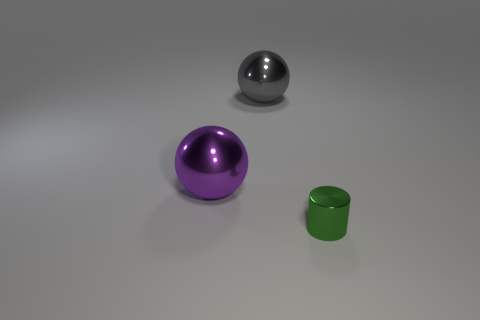Add 3 purple shiny objects. How many objects exist? 6 Subtract all cylinders. How many objects are left? 2 Add 2 green metal objects. How many green metal objects exist? 3 Subtract 0 yellow blocks. How many objects are left? 3 Subtract all blue shiny blocks. Subtract all metallic things. How many objects are left? 0 Add 3 purple objects. How many purple objects are left? 4 